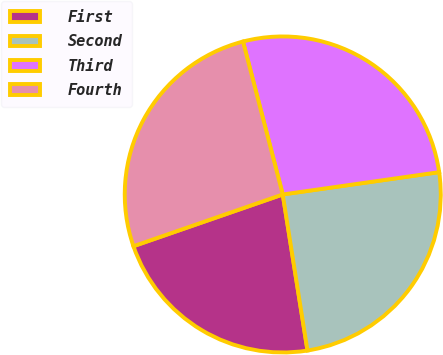Convert chart to OTSL. <chart><loc_0><loc_0><loc_500><loc_500><pie_chart><fcel>First<fcel>Second<fcel>Third<fcel>Fourth<nl><fcel>22.19%<fcel>24.75%<fcel>26.79%<fcel>26.26%<nl></chart> 